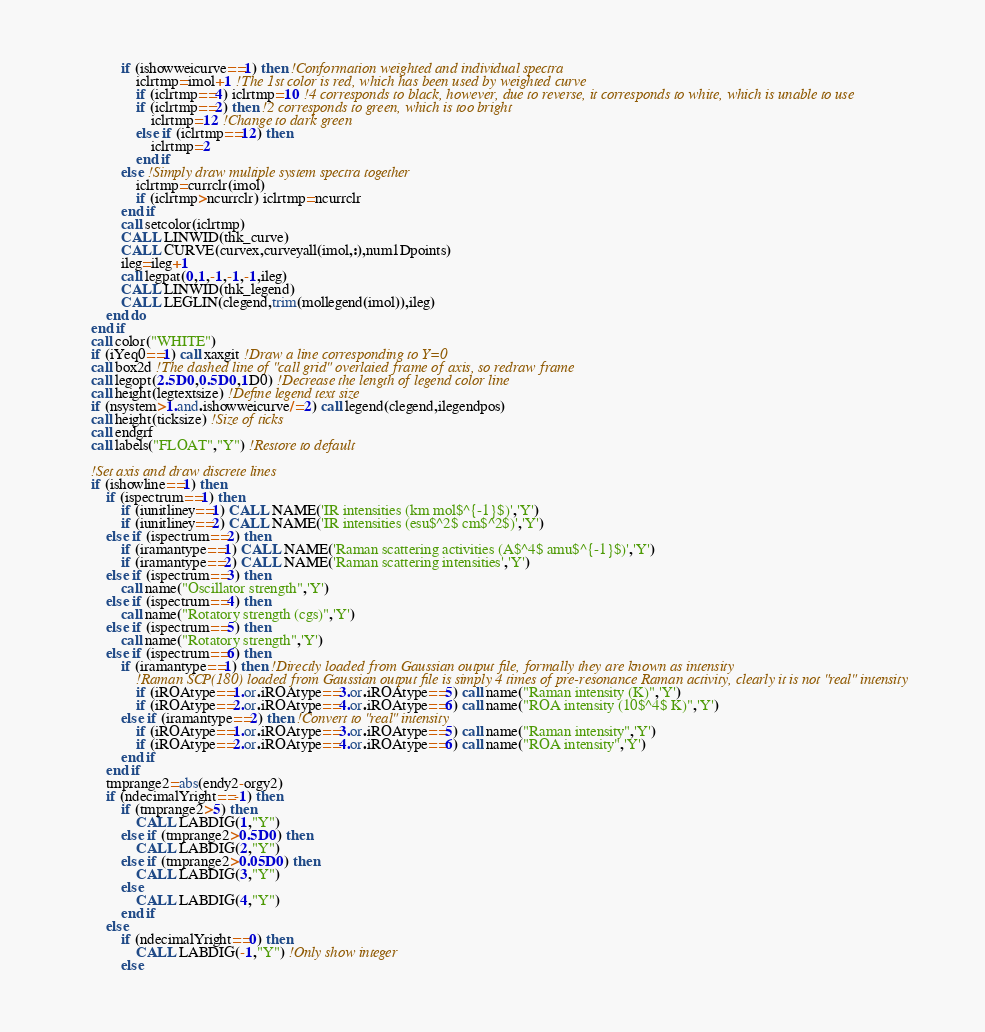Convert code to text. <code><loc_0><loc_0><loc_500><loc_500><_FORTRAN_>                if (ishowweicurve==1) then !Conformation weighted and individual spectra
				    iclrtmp=imol+1 !The 1st color is red, which has been used by weighted curve
				    if (iclrtmp==4) iclrtmp=10 !4 corresponds to black, however, due to reverse, it corresponds to white, which is unable to use
				    if (iclrtmp==2) then !2 corresponds to green, which is too bright
					    iclrtmp=12 !Change to dark green
				    else if (iclrtmp==12) then
					    iclrtmp=2
				    end if
                else !Simply draw multiple system spectra together
                    iclrtmp=currclr(imol)
                    if (iclrtmp>ncurrclr) iclrtmp=ncurrclr
                end if
				call setcolor(iclrtmp)
				CALL LINWID(thk_curve)
				CALL CURVE(curvex,curveyall(imol,:),num1Dpoints)
				ileg=ileg+1
				call legpat(0,1,-1,-1,-1,ileg)
				CALL LINWID(thk_legend)
				CALL LEGLIN(clegend,trim(mollegend(imol)),ileg)
			end do
		end if
		call color("WHITE")
		if (iYeq0==1) call xaxgit !Draw a line corresponding to Y=0
		call box2d !The dashed line of "call grid" overlaied frame of axis, so redraw frame
		call legopt(2.5D0,0.5D0,1D0) !Decrease the length of legend color line
        call height(legtextsize) !Define legend text size
		if (nsystem>1.and.ishowweicurve/=2) call legend(clegend,ilegendpos)
        call height(ticksize) !Size of ticks
		call endgrf
        call labels("FLOAT","Y") !Restore to default
		
        !Set axis and draw discrete lines
		if (ishowline==1) then
			if (ispectrum==1) then
				if (iunitliney==1) CALL NAME('IR intensities (km mol$^{-1}$)','Y')
				if (iunitliney==2) CALL NAME('IR intensities (esu$^2$ cm$^2$)','Y')
			else if (ispectrum==2) then
				if (iramantype==1) CALL NAME('Raman scattering activities (A$^4$ amu$^{-1}$)','Y')
				if (iramantype==2) CALL NAME('Raman scattering intensities','Y')
			else if (ispectrum==3) then
				call name("Oscillator strength",'Y')
			else if (ispectrum==4) then
				call name("Rotatory strength (cgs)",'Y')
			else if (ispectrum==5) then
				call name("Rotatory strength",'Y')
			else if (ispectrum==6) then
				if (iramantype==1) then !Directly loaded from Gaussian output file, formally they are known as intensity
					!Raman SCP(180) loaded from Gaussian output file is simply 4 times of pre-resonance Raman activity, clearly it is not "real" intensity
					if (iROAtype==1.or.iROAtype==3.or.iROAtype==5) call name("Raman intensity (K)",'Y')
					if (iROAtype==2.or.iROAtype==4.or.iROAtype==6) call name("ROA intensity (10$^4$ K)",'Y')
				else if (iramantype==2) then !Convert to "real" intensity
					if (iROAtype==1.or.iROAtype==3.or.iROAtype==5) call name("Raman intensity",'Y')
					if (iROAtype==2.or.iROAtype==4.or.iROAtype==6) call name("ROA intensity",'Y')
				end if
			end if
			tmprange2=abs(endy2-orgy2)
            if (ndecimalYright==-1) then
			    if (tmprange2>5) then
				    CALL LABDIG(1,"Y")
			    else if (tmprange2>0.5D0) then
				    CALL LABDIG(2,"Y")
			    else if (tmprange2>0.05D0) then
				    CALL LABDIG(3,"Y")
			    else
				    CALL LABDIG(4,"Y")
			    end if
            else
                if (ndecimalYright==0) then
                    CALL LABDIG(-1,"Y") !Only show integer
                else</code> 